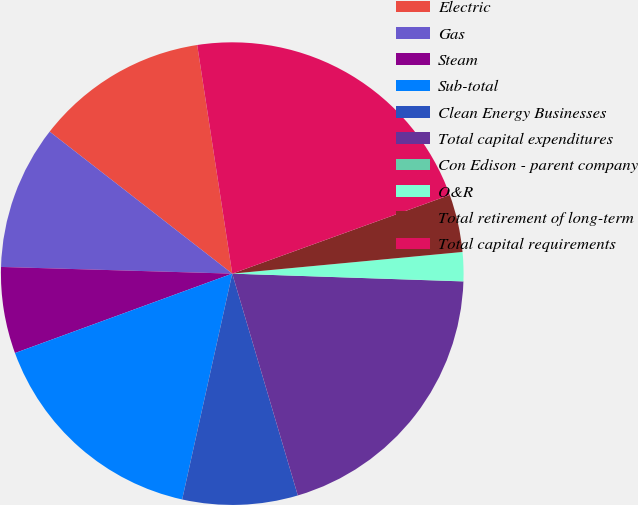Convert chart. <chart><loc_0><loc_0><loc_500><loc_500><pie_chart><fcel>Electric<fcel>Gas<fcel>Steam<fcel>Sub-total<fcel>Clean Energy Businesses<fcel>Total capital expenditures<fcel>Con Edison - parent company<fcel>O&R<fcel>Total retirement of long-term<fcel>Total capital requirements<nl><fcel>12.06%<fcel>10.06%<fcel>6.04%<fcel>15.95%<fcel>8.05%<fcel>19.89%<fcel>0.01%<fcel>2.02%<fcel>4.03%<fcel>21.9%<nl></chart> 